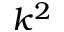<formula> <loc_0><loc_0><loc_500><loc_500>k ^ { 2 }</formula> 